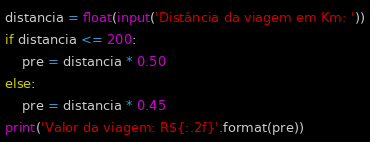<code> <loc_0><loc_0><loc_500><loc_500><_Python_>distancia = float(input('Distância da viagem em Km: '))
if distancia <= 200:
    pre = distancia * 0.50
else:
    pre = distancia * 0.45
print('Valor da viagem: R${:.2f}'.format(pre))
</code> 